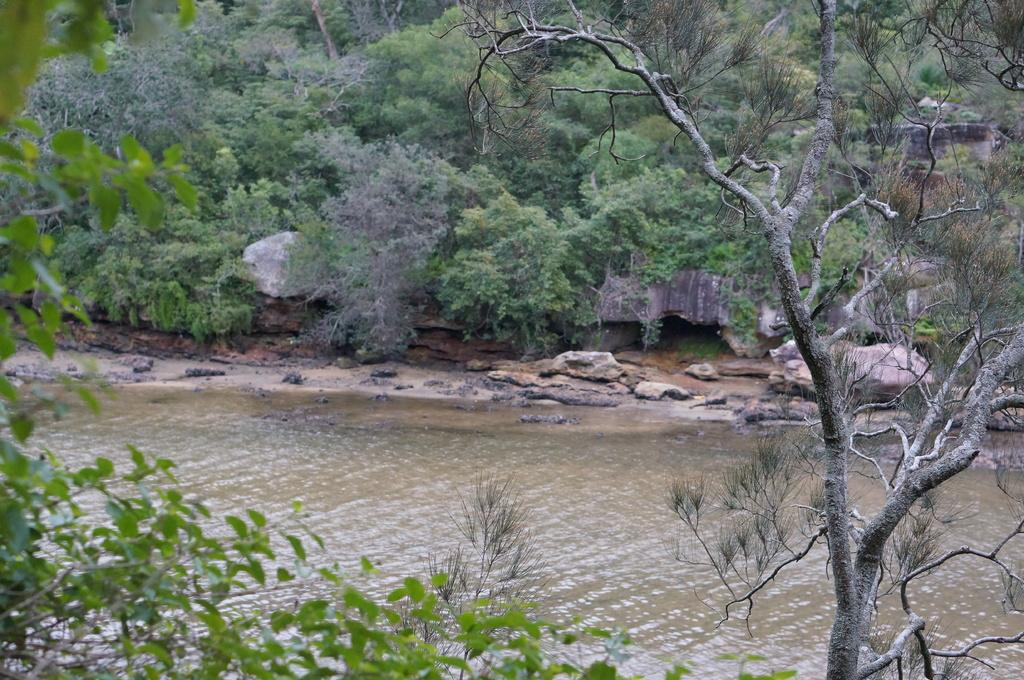What type of vegetation can be seen in the image? There are trees in the image. What natural element is visible in the image besides trees? There is water visible in the image. What other objects can be seen in the image? There are rocks in the image. What type of hat is the mom wearing in the image? There is no mom or hat present in the image; it only features trees, water, and rocks. 